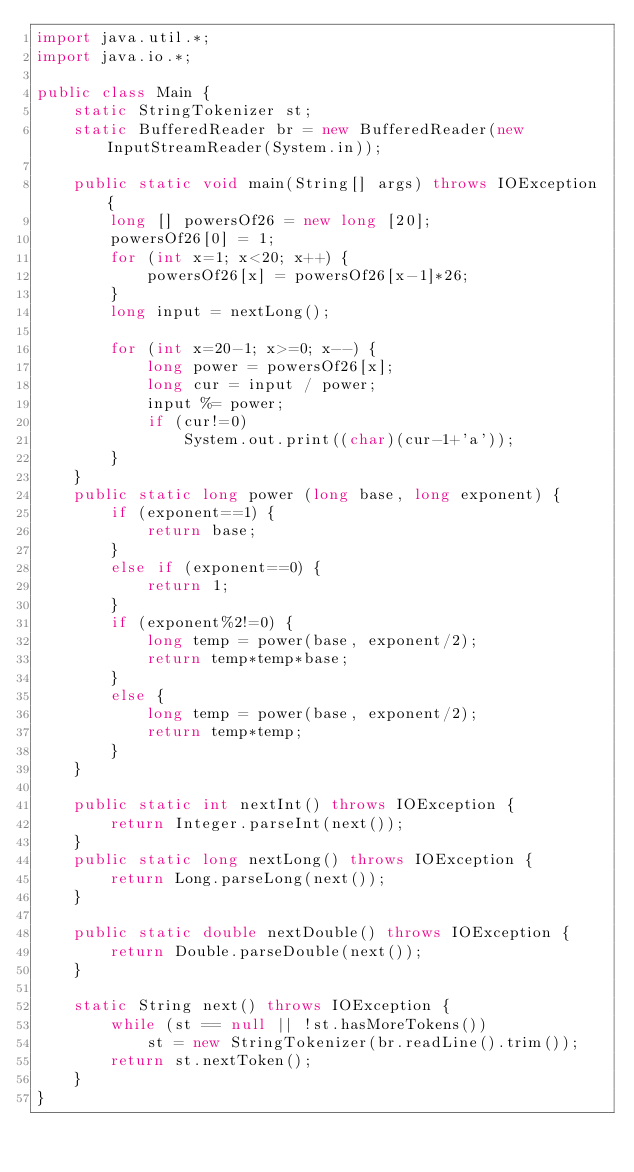Convert code to text. <code><loc_0><loc_0><loc_500><loc_500><_Java_>import java.util.*;
import java.io.*;

public class Main {
    static StringTokenizer st;
    static BufferedReader br = new BufferedReader(new InputStreamReader(System.in));

    public static void main(String[] args) throws IOException {
        long [] powersOf26 = new long [20];
        powersOf26[0] = 1;
        for (int x=1; x<20; x++) {
            powersOf26[x] = powersOf26[x-1]*26;
        }
        long input = nextLong();

        for (int x=20-1; x>=0; x--) {
            long power = powersOf26[x];
            long cur = input / power;
            input %= power;
            if (cur!=0)
                System.out.print((char)(cur-1+'a'));
        }
    }
    public static long power (long base, long exponent) {
        if (exponent==1) {
            return base;
        }
        else if (exponent==0) {
            return 1;
        }
        if (exponent%2!=0) {
            long temp = power(base, exponent/2);
            return temp*temp*base;
        }
        else {
            long temp = power(base, exponent/2);
            return temp*temp;
        }
    }
    
    public static int nextInt() throws IOException {
        return Integer.parseInt(next());
    }
    public static long nextLong() throws IOException {
        return Long.parseLong(next());
    }

    public static double nextDouble() throws IOException {
        return Double.parseDouble(next());
    }

    static String next() throws IOException {
        while (st == null || !st.hasMoreTokens())
            st = new StringTokenizer(br.readLine().trim());
        return st.nextToken();
    }
}


</code> 